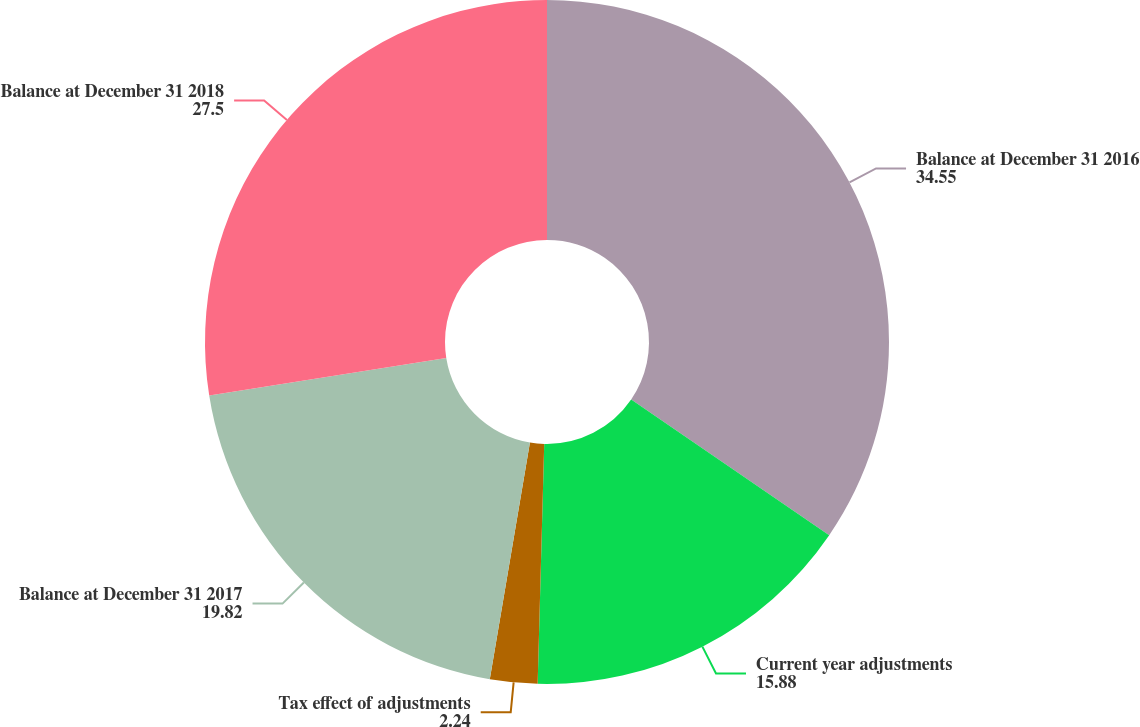Convert chart to OTSL. <chart><loc_0><loc_0><loc_500><loc_500><pie_chart><fcel>Balance at December 31 2016<fcel>Current year adjustments<fcel>Tax effect of adjustments<fcel>Balance at December 31 2017<fcel>Balance at December 31 2018<nl><fcel>34.55%<fcel>15.88%<fcel>2.24%<fcel>19.82%<fcel>27.5%<nl></chart> 